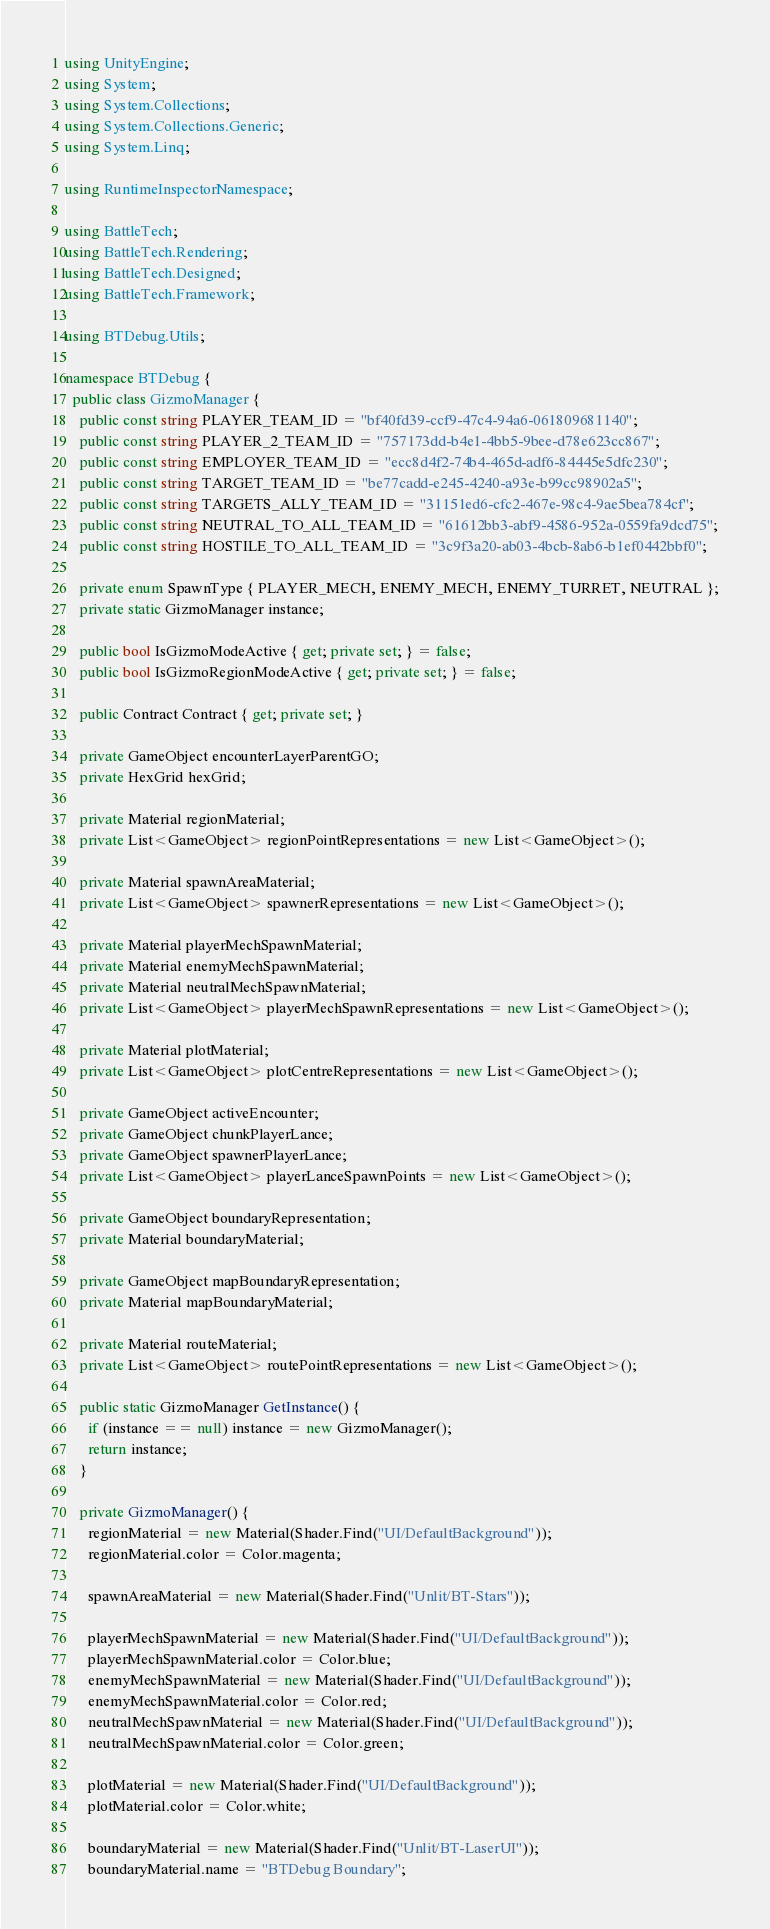Convert code to text. <code><loc_0><loc_0><loc_500><loc_500><_C#_>using UnityEngine;
using System;
using System.Collections;
using System.Collections.Generic;
using System.Linq;

using RuntimeInspectorNamespace;

using BattleTech;
using BattleTech.Rendering;
using BattleTech.Designed;
using BattleTech.Framework;

using BTDebug.Utils;

namespace BTDebug {
  public class GizmoManager {
    public const string PLAYER_TEAM_ID = "bf40fd39-ccf9-47c4-94a6-061809681140";
    public const string PLAYER_2_TEAM_ID = "757173dd-b4e1-4bb5-9bee-d78e623cc867";
    public const string EMPLOYER_TEAM_ID = "ecc8d4f2-74b4-465d-adf6-84445e5dfc230";
    public const string TARGET_TEAM_ID = "be77cadd-e245-4240-a93e-b99cc98902a5";
    public const string TARGETS_ALLY_TEAM_ID = "31151ed6-cfc2-467e-98c4-9ae5bea784cf";
    public const string NEUTRAL_TO_ALL_TEAM_ID = "61612bb3-abf9-4586-952a-0559fa9dcd75";
    public const string HOSTILE_TO_ALL_TEAM_ID = "3c9f3a20-ab03-4bcb-8ab6-b1ef0442bbf0";

    private enum SpawnType { PLAYER_MECH, ENEMY_MECH, ENEMY_TURRET, NEUTRAL };
    private static GizmoManager instance;

    public bool IsGizmoModeActive { get; private set; } = false;
    public bool IsGizmoRegionModeActive { get; private set; } = false;

    public Contract Contract { get; private set; }

    private GameObject encounterLayerParentGO;
    private HexGrid hexGrid;

    private Material regionMaterial;
    private List<GameObject> regionPointRepresentations = new List<GameObject>();

    private Material spawnAreaMaterial;
    private List<GameObject> spawnerRepresentations = new List<GameObject>();

    private Material playerMechSpawnMaterial;
    private Material enemyMechSpawnMaterial;
    private Material neutralMechSpawnMaterial;
    private List<GameObject> playerMechSpawnRepresentations = new List<GameObject>();

    private Material plotMaterial;
    private List<GameObject> plotCentreRepresentations = new List<GameObject>();

    private GameObject activeEncounter;
    private GameObject chunkPlayerLance;
    private GameObject spawnerPlayerLance;
    private List<GameObject> playerLanceSpawnPoints = new List<GameObject>();

    private GameObject boundaryRepresentation;
    private Material boundaryMaterial;

    private GameObject mapBoundaryRepresentation;
    private Material mapBoundaryMaterial;

    private Material routeMaterial;
    private List<GameObject> routePointRepresentations = new List<GameObject>();

    public static GizmoManager GetInstance() {
      if (instance == null) instance = new GizmoManager();
      return instance;
    }

    private GizmoManager() {
      regionMaterial = new Material(Shader.Find("UI/DefaultBackground"));
      regionMaterial.color = Color.magenta;

      spawnAreaMaterial = new Material(Shader.Find("Unlit/BT-Stars"));

      playerMechSpawnMaterial = new Material(Shader.Find("UI/DefaultBackground"));
      playerMechSpawnMaterial.color = Color.blue;
      enemyMechSpawnMaterial = new Material(Shader.Find("UI/DefaultBackground"));
      enemyMechSpawnMaterial.color = Color.red;
      neutralMechSpawnMaterial = new Material(Shader.Find("UI/DefaultBackground"));
      neutralMechSpawnMaterial.color = Color.green;

      plotMaterial = new Material(Shader.Find("UI/DefaultBackground"));
      plotMaterial.color = Color.white;

      boundaryMaterial = new Material(Shader.Find("Unlit/BT-LaserUI"));
      boundaryMaterial.name = "BTDebug Boundary";</code> 